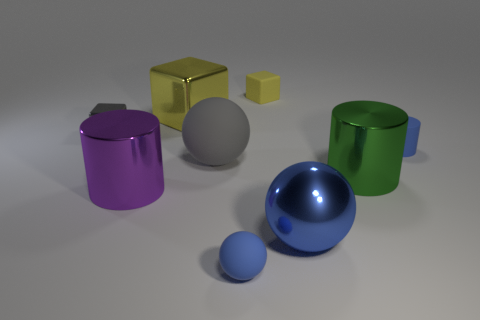How many other things are there of the same material as the small cylinder?
Offer a very short reply. 3. There is a small blue thing that is to the right of the big cylinder on the right side of the matte thing behind the tiny blue cylinder; what is it made of?
Your response must be concise. Rubber. There is a big thing that is behind the large rubber sphere; what is its color?
Provide a short and direct response. Yellow. Are there any other things that have the same shape as the big yellow object?
Give a very brief answer. Yes. There is a blue ball that is on the right side of the small thing that is in front of the tiny rubber cylinder; what is its size?
Your answer should be very brief. Large. Are there the same number of gray objects that are left of the big blue shiny ball and yellow metallic cubes that are in front of the big purple metal thing?
Provide a succinct answer. No. Are there any other things that have the same size as the blue metallic ball?
Ensure brevity in your answer.  Yes. What is the color of the big ball that is made of the same material as the tiny yellow thing?
Provide a succinct answer. Gray. Is the small blue ball made of the same material as the yellow block right of the big matte thing?
Offer a very short reply. Yes. The small rubber thing that is in front of the tiny gray thing and to the left of the small rubber cylinder is what color?
Offer a terse response. Blue. 